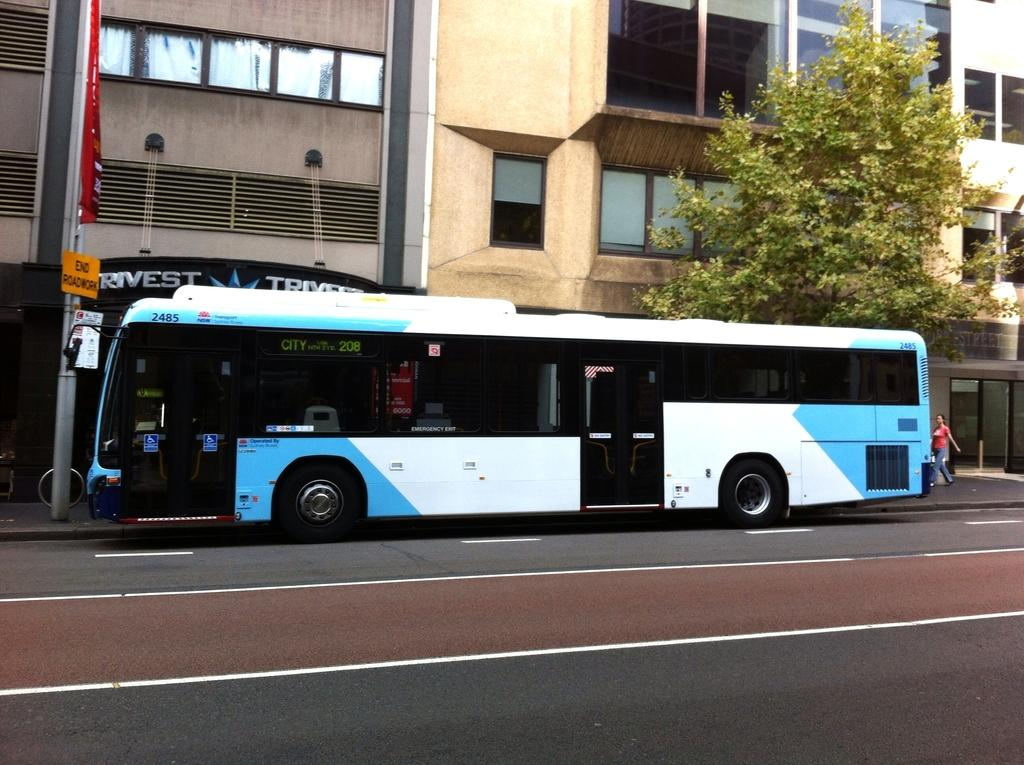What is the main subject in the center of the image? There is a bus in the center of the image. What can be seen in the background of the image? Buildings, trees, poles, boards, and persons are present in the background of the image. What type of surface is visible at the bottom of the image? There is a road at the bottom of the image. What type of sweater is being worn by the soup in the image? There is no sweater or soup present in the image. How does the bus turn around in the image? The bus does not turn around in the image; it is stationary in the center. 